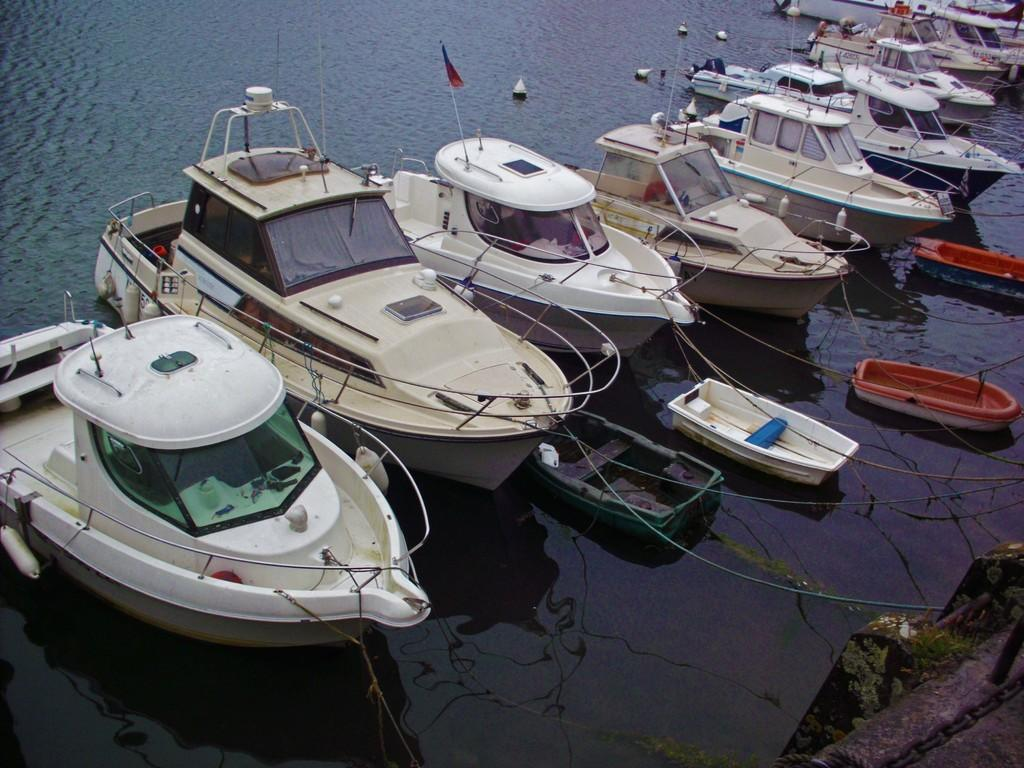What type of vehicles are in the image? There are boats in the image. Where are the boats located? The boats are on the water. What type of key is used to unlock the boats in the image? There are no keys present in the image, and the boats are on the water, not locked. What color is the hair of the person driving the boat in the image? There are no people visible in the image, so we cannot determine the color of anyone's hair. 